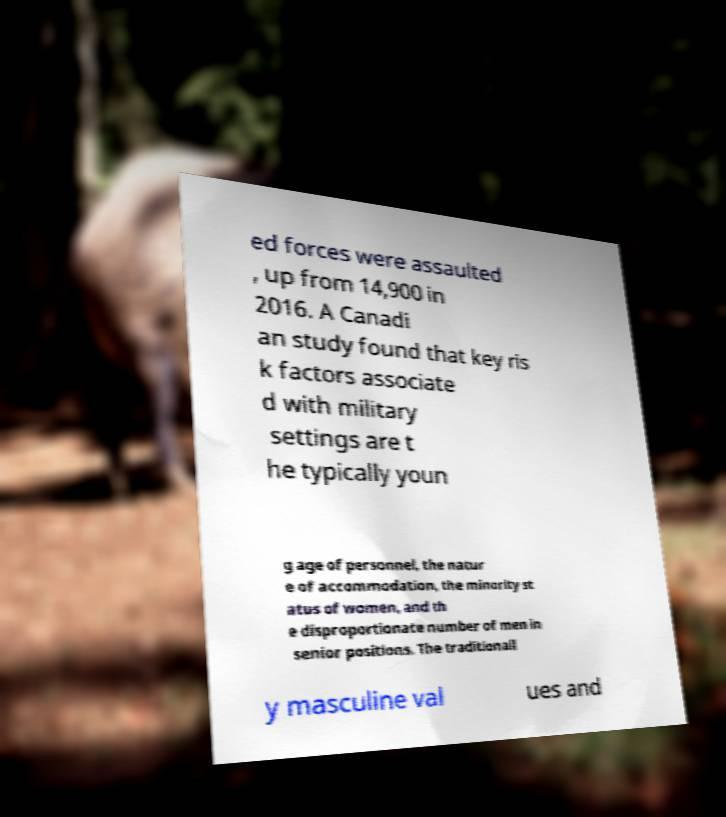Could you assist in decoding the text presented in this image and type it out clearly? ed forces were assaulted , up from 14,900 in 2016. A Canadi an study found that key ris k factors associate d with military settings are t he typically youn g age of personnel, the natur e of accommodation, the minority st atus of women, and th e disproportionate number of men in senior positions. The traditionall y masculine val ues and 